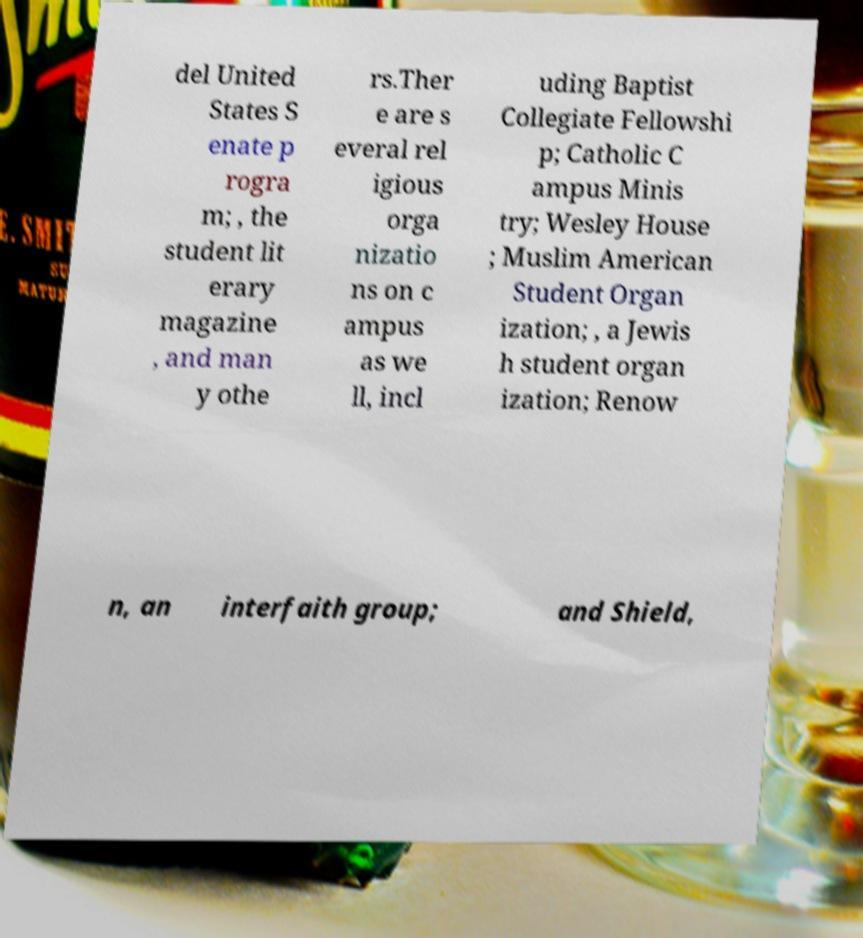Please identify and transcribe the text found in this image. del United States S enate p rogra m; , the student lit erary magazine , and man y othe rs.Ther e are s everal rel igious orga nizatio ns on c ampus as we ll, incl uding Baptist Collegiate Fellowshi p; Catholic C ampus Minis try; Wesley House ; Muslim American Student Organ ization; , a Jewis h student organ ization; Renow n, an interfaith group; and Shield, 